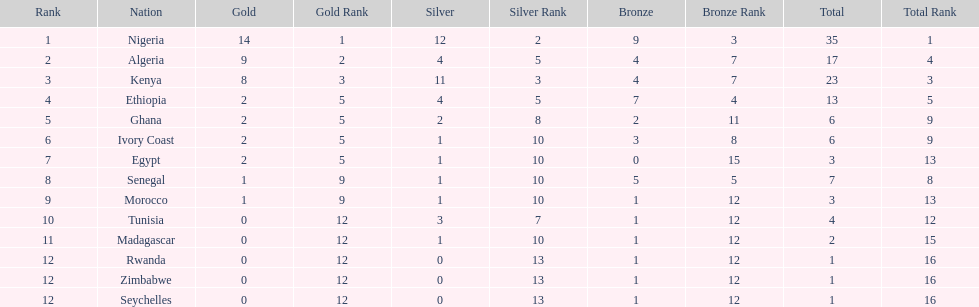Can you give me this table as a dict? {'header': ['Rank', 'Nation', 'Gold', 'Gold Rank', 'Silver', 'Silver Rank', 'Bronze', 'Bronze Rank', 'Total', 'Total Rank'], 'rows': [['1', 'Nigeria', '14', '1', '12', '2', '9', '3', '35', '1'], ['2', 'Algeria', '9', '2', '4', '5', '4', '7', '17', '4'], ['3', 'Kenya', '8', '3', '11', '3', '4', '7', '23', '3'], ['4', 'Ethiopia', '2', '5', '4', '5', '7', '4', '13', '5'], ['5', 'Ghana', '2', '5', '2', '8', '2', '11', '6', '9'], ['6', 'Ivory Coast', '2', '5', '1', '10', '3', '8', '6', '9'], ['7', 'Egypt', '2', '5', '1', '10', '0', '15', '3', '13'], ['8', 'Senegal', '1', '9', '1', '10', '5', '5', '7', '8'], ['9', 'Morocco', '1', '9', '1', '10', '1', '12', '3', '13'], ['10', 'Tunisia', '0', '12', '3', '7', '1', '12', '4', '12'], ['11', 'Madagascar', '0', '12', '1', '10', '1', '12', '2', '15'], ['12', 'Rwanda', '0', '12', '0', '13', '1', '12', '1', '16'], ['12', 'Zimbabwe', '0', '12', '0', '13', '1', '12', '1', '16'], ['12', 'Seychelles', '0', '12', '0', '13', '1', '12', '1', '16']]} The nation above algeria Nigeria. 